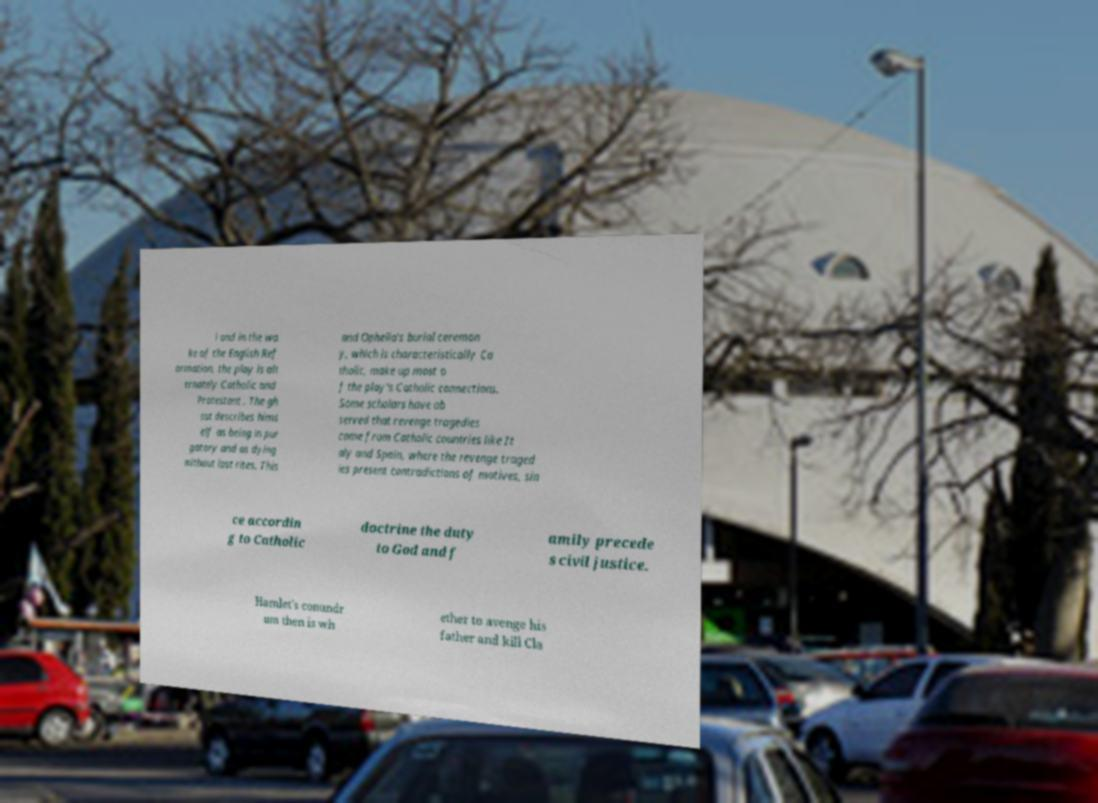Please identify and transcribe the text found in this image. l and in the wa ke of the English Ref ormation, the play is alt ernately Catholic and Protestant . The gh ost describes hims elf as being in pur gatory and as dying without last rites. This and Ophelia's burial ceremon y, which is characteristically Ca tholic, make up most o f the play's Catholic connections. Some scholars have ob served that revenge tragedies come from Catholic countries like It aly and Spain, where the revenge traged ies present contradictions of motives, sin ce accordin g to Catholic doctrine the duty to God and f amily precede s civil justice. Hamlet's conundr um then is wh ether to avenge his father and kill Cla 